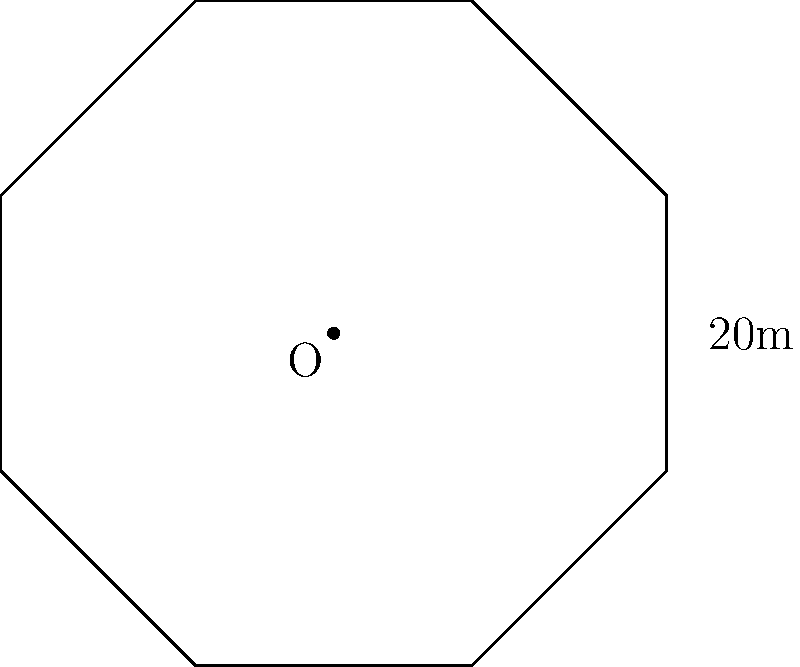Your custom-designed helipad on the roof is shaped like a regular octagon. If the distance from the center to any vertex of the octagon is 20 meters, what is the total area of the helipad in square meters? Round your answer to the nearest whole number. To find the area of a regular octagon, we can use the formula:

$$ A = 2a^2(1 + \sqrt{2}) $$

Where $a$ is the length of one side of the octagon.

Step 1: Find the side length $a$ using the radius $r$ (distance from center to vertex)
$$ a = r \sqrt{2 - \sqrt{2}} $$
$$ a = 20 \sqrt{2 - \sqrt{2}} \approx 15.3073 \text{ m} $$

Step 2: Apply the area formula
$$ A = 2(15.3073)^2(1 + \sqrt{2}) $$
$$ A = 2 \cdot 234.3136 \cdot 2.4142 $$
$$ A = 1131.3719 \text{ m}^2 $$

Step 3: Round to the nearest whole number
$$ A \approx 1131 \text{ m}^2 $$
Answer: 1131 m² 